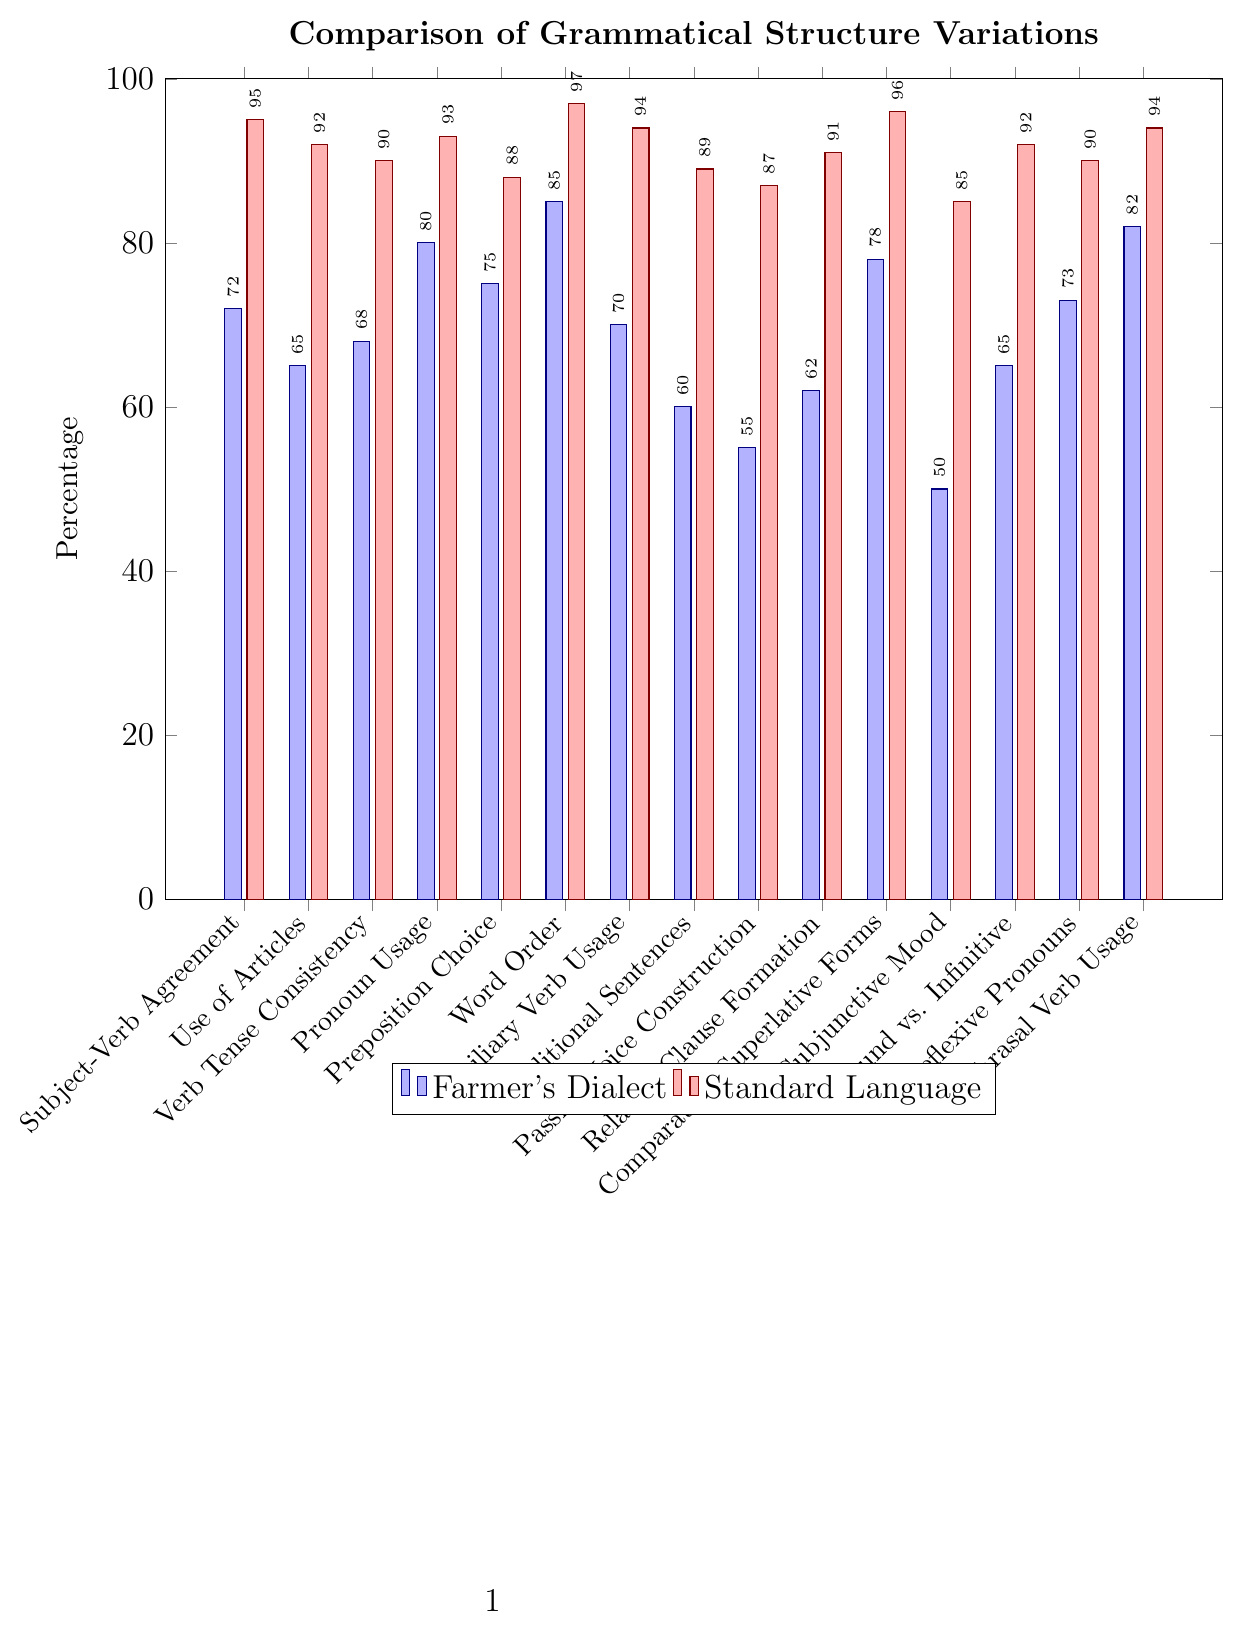What's the difference in percentage between the Farmer's Dialect and Standard Language for 'Pronoun Usage'? First, find the values for 'Pronoun Usage' for both groups: Farmer's Dialect (80) and Standard Language (93). Then, calculate the difference: 93 - 80 = 13
Answer: 13 Which grammatical structure shows the highest variation between the Farmer's Dialect and Standard Language? Look for the grammatical structure with the largest difference between the two sets of values. The differences are calculated as follows: Subject-Verb Agreement (95-72=23), Use of Articles (92-65=27), Verb Tense Consistency (90-68=22), Pronoun Usage (93-80=13), Preposition Choice (88-75=13), Word Order (97-85=12), Auxiliary Verb Usage (94-70=24), Conditional Sentences (89-60=29), Passive Voice Construction (87-55=32), Relative Clause Formation (91-62=29), Comparative/Superlative Forms (96-78=18), Subjunctive Mood (85-50=35), Gerund vs. Infinitive (92-65=27), Reflexive Pronouns (90-73=17), Phrasal Verb Usage (94-82=12). The largest difference is for 'Subjunctive Mood': 35
Answer: Subjunctive Mood What's the total percentage for 'Verb Tense Consistency' and 'Word Order' for the Farmer's Dialect? Add the values for 'Verb Tense Consistency' (68) and 'Word Order' (85): 68 + 85 = 153
Answer: 153 In how many categories is the percentage for the Farmer's Dialect lower than 70? Identify categories with lower values: 'Use of Articles' (65), 'Verb Tense Consistency' (68), 'Auxiliary Verb Usage' (70), 'Conditional Sentences' (60), 'Passive Voice Construction' (55), 'Relative Clause Formation' (62), 'Subjunctive Mood' (50), 'Gerund vs. Infinitive' (65), 'Reflexive Pronouns' (73 - not lower than 70). Count these categories: 7
Answer: 7 Is there any category where both the Farmer's Dialect and Standard Language have percentages higher than 90? Check both values above 90 for all categories: No such category exists.
Answer: No 